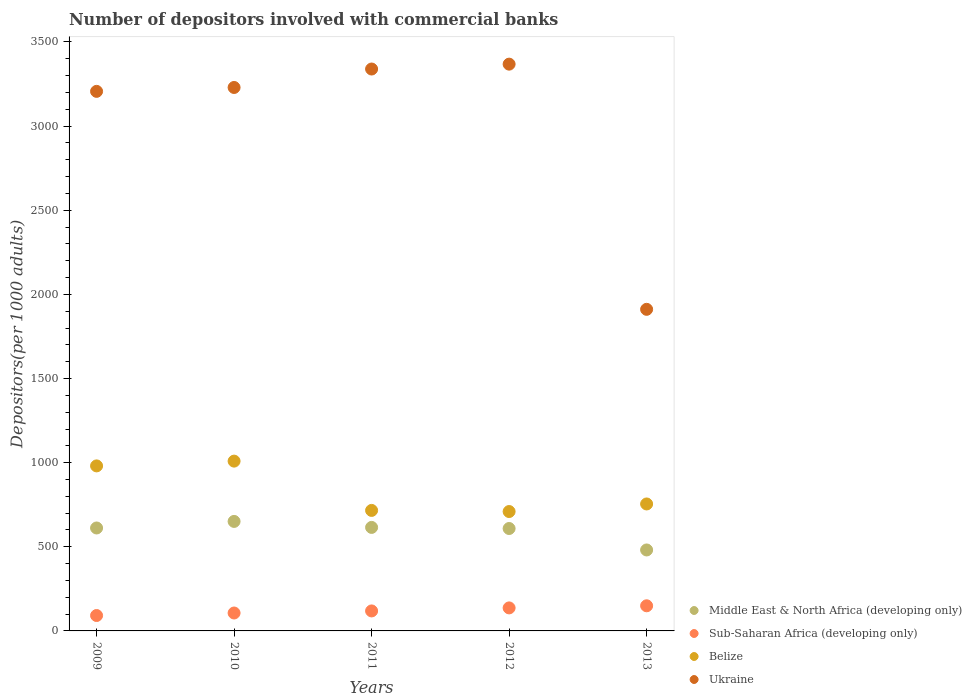How many different coloured dotlines are there?
Provide a short and direct response. 4. What is the number of depositors involved with commercial banks in Belize in 2013?
Ensure brevity in your answer.  754.53. Across all years, what is the maximum number of depositors involved with commercial banks in Ukraine?
Your response must be concise. 3368.39. Across all years, what is the minimum number of depositors involved with commercial banks in Middle East & North Africa (developing only)?
Provide a short and direct response. 481.17. In which year was the number of depositors involved with commercial banks in Ukraine minimum?
Provide a succinct answer. 2013. What is the total number of depositors involved with commercial banks in Ukraine in the graph?
Offer a terse response. 1.51e+04. What is the difference between the number of depositors involved with commercial banks in Sub-Saharan Africa (developing only) in 2011 and that in 2012?
Ensure brevity in your answer.  -17.98. What is the difference between the number of depositors involved with commercial banks in Sub-Saharan Africa (developing only) in 2009 and the number of depositors involved with commercial banks in Belize in 2012?
Provide a succinct answer. -617.99. What is the average number of depositors involved with commercial banks in Belize per year?
Make the answer very short. 834.02. In the year 2012, what is the difference between the number of depositors involved with commercial banks in Ukraine and number of depositors involved with commercial banks in Sub-Saharan Africa (developing only)?
Make the answer very short. 3231.6. In how many years, is the number of depositors involved with commercial banks in Ukraine greater than 2000?
Ensure brevity in your answer.  4. What is the ratio of the number of depositors involved with commercial banks in Ukraine in 2011 to that in 2013?
Make the answer very short. 1.75. Is the number of depositors involved with commercial banks in Sub-Saharan Africa (developing only) in 2009 less than that in 2010?
Ensure brevity in your answer.  Yes. What is the difference between the highest and the second highest number of depositors involved with commercial banks in Ukraine?
Your answer should be very brief. 28.98. What is the difference between the highest and the lowest number of depositors involved with commercial banks in Middle East & North Africa (developing only)?
Make the answer very short. 169.6. Is it the case that in every year, the sum of the number of depositors involved with commercial banks in Middle East & North Africa (developing only) and number of depositors involved with commercial banks in Belize  is greater than the sum of number of depositors involved with commercial banks in Sub-Saharan Africa (developing only) and number of depositors involved with commercial banks in Ukraine?
Your response must be concise. Yes. Is it the case that in every year, the sum of the number of depositors involved with commercial banks in Belize and number of depositors involved with commercial banks in Middle East & North Africa (developing only)  is greater than the number of depositors involved with commercial banks in Ukraine?
Offer a very short reply. No. Is the number of depositors involved with commercial banks in Ukraine strictly less than the number of depositors involved with commercial banks in Sub-Saharan Africa (developing only) over the years?
Your response must be concise. No. Does the graph contain grids?
Your response must be concise. No. Where does the legend appear in the graph?
Offer a very short reply. Bottom right. What is the title of the graph?
Ensure brevity in your answer.  Number of depositors involved with commercial banks. Does "Eritrea" appear as one of the legend labels in the graph?
Provide a short and direct response. No. What is the label or title of the Y-axis?
Keep it short and to the point. Depositors(per 1000 adults). What is the Depositors(per 1000 adults) of Middle East & North Africa (developing only) in 2009?
Provide a short and direct response. 611.77. What is the Depositors(per 1000 adults) in Sub-Saharan Africa (developing only) in 2009?
Provide a succinct answer. 91.54. What is the Depositors(per 1000 adults) of Belize in 2009?
Give a very brief answer. 980.77. What is the Depositors(per 1000 adults) of Ukraine in 2009?
Make the answer very short. 3206.64. What is the Depositors(per 1000 adults) in Middle East & North Africa (developing only) in 2010?
Offer a terse response. 650.77. What is the Depositors(per 1000 adults) in Sub-Saharan Africa (developing only) in 2010?
Make the answer very short. 106.49. What is the Depositors(per 1000 adults) in Belize in 2010?
Your response must be concise. 1009.11. What is the Depositors(per 1000 adults) in Ukraine in 2010?
Provide a short and direct response. 3229.69. What is the Depositors(per 1000 adults) of Middle East & North Africa (developing only) in 2011?
Provide a short and direct response. 615.16. What is the Depositors(per 1000 adults) of Sub-Saharan Africa (developing only) in 2011?
Offer a terse response. 118.8. What is the Depositors(per 1000 adults) of Belize in 2011?
Your answer should be compact. 716.16. What is the Depositors(per 1000 adults) of Ukraine in 2011?
Offer a very short reply. 3339.41. What is the Depositors(per 1000 adults) in Middle East & North Africa (developing only) in 2012?
Keep it short and to the point. 608.64. What is the Depositors(per 1000 adults) in Sub-Saharan Africa (developing only) in 2012?
Provide a succinct answer. 136.78. What is the Depositors(per 1000 adults) of Belize in 2012?
Your answer should be compact. 709.54. What is the Depositors(per 1000 adults) of Ukraine in 2012?
Provide a short and direct response. 3368.39. What is the Depositors(per 1000 adults) of Middle East & North Africa (developing only) in 2013?
Offer a terse response. 481.17. What is the Depositors(per 1000 adults) in Sub-Saharan Africa (developing only) in 2013?
Your answer should be compact. 149.33. What is the Depositors(per 1000 adults) in Belize in 2013?
Your answer should be compact. 754.53. What is the Depositors(per 1000 adults) of Ukraine in 2013?
Make the answer very short. 1911.24. Across all years, what is the maximum Depositors(per 1000 adults) of Middle East & North Africa (developing only)?
Ensure brevity in your answer.  650.77. Across all years, what is the maximum Depositors(per 1000 adults) of Sub-Saharan Africa (developing only)?
Give a very brief answer. 149.33. Across all years, what is the maximum Depositors(per 1000 adults) of Belize?
Offer a terse response. 1009.11. Across all years, what is the maximum Depositors(per 1000 adults) in Ukraine?
Make the answer very short. 3368.39. Across all years, what is the minimum Depositors(per 1000 adults) of Middle East & North Africa (developing only)?
Offer a very short reply. 481.17. Across all years, what is the minimum Depositors(per 1000 adults) in Sub-Saharan Africa (developing only)?
Ensure brevity in your answer.  91.54. Across all years, what is the minimum Depositors(per 1000 adults) in Belize?
Keep it short and to the point. 709.54. Across all years, what is the minimum Depositors(per 1000 adults) in Ukraine?
Provide a short and direct response. 1911.24. What is the total Depositors(per 1000 adults) in Middle East & North Africa (developing only) in the graph?
Your answer should be compact. 2967.5. What is the total Depositors(per 1000 adults) of Sub-Saharan Africa (developing only) in the graph?
Provide a short and direct response. 602.95. What is the total Depositors(per 1000 adults) of Belize in the graph?
Ensure brevity in your answer.  4170.11. What is the total Depositors(per 1000 adults) in Ukraine in the graph?
Give a very brief answer. 1.51e+04. What is the difference between the Depositors(per 1000 adults) in Middle East & North Africa (developing only) in 2009 and that in 2010?
Provide a succinct answer. -39. What is the difference between the Depositors(per 1000 adults) of Sub-Saharan Africa (developing only) in 2009 and that in 2010?
Keep it short and to the point. -14.95. What is the difference between the Depositors(per 1000 adults) of Belize in 2009 and that in 2010?
Make the answer very short. -28.34. What is the difference between the Depositors(per 1000 adults) of Ukraine in 2009 and that in 2010?
Provide a succinct answer. -23.06. What is the difference between the Depositors(per 1000 adults) in Middle East & North Africa (developing only) in 2009 and that in 2011?
Offer a very short reply. -3.39. What is the difference between the Depositors(per 1000 adults) in Sub-Saharan Africa (developing only) in 2009 and that in 2011?
Ensure brevity in your answer.  -27.26. What is the difference between the Depositors(per 1000 adults) in Belize in 2009 and that in 2011?
Your response must be concise. 264.62. What is the difference between the Depositors(per 1000 adults) of Ukraine in 2009 and that in 2011?
Make the answer very short. -132.77. What is the difference between the Depositors(per 1000 adults) in Middle East & North Africa (developing only) in 2009 and that in 2012?
Offer a terse response. 3.13. What is the difference between the Depositors(per 1000 adults) in Sub-Saharan Africa (developing only) in 2009 and that in 2012?
Your answer should be compact. -45.24. What is the difference between the Depositors(per 1000 adults) in Belize in 2009 and that in 2012?
Provide a short and direct response. 271.24. What is the difference between the Depositors(per 1000 adults) in Ukraine in 2009 and that in 2012?
Offer a very short reply. -161.75. What is the difference between the Depositors(per 1000 adults) in Middle East & North Africa (developing only) in 2009 and that in 2013?
Offer a terse response. 130.6. What is the difference between the Depositors(per 1000 adults) of Sub-Saharan Africa (developing only) in 2009 and that in 2013?
Your response must be concise. -57.79. What is the difference between the Depositors(per 1000 adults) in Belize in 2009 and that in 2013?
Offer a very short reply. 226.24. What is the difference between the Depositors(per 1000 adults) in Ukraine in 2009 and that in 2013?
Provide a short and direct response. 1295.4. What is the difference between the Depositors(per 1000 adults) of Middle East & North Africa (developing only) in 2010 and that in 2011?
Your answer should be compact. 35.61. What is the difference between the Depositors(per 1000 adults) of Sub-Saharan Africa (developing only) in 2010 and that in 2011?
Your answer should be compact. -12.31. What is the difference between the Depositors(per 1000 adults) of Belize in 2010 and that in 2011?
Ensure brevity in your answer.  292.95. What is the difference between the Depositors(per 1000 adults) in Ukraine in 2010 and that in 2011?
Your response must be concise. -109.71. What is the difference between the Depositors(per 1000 adults) of Middle East & North Africa (developing only) in 2010 and that in 2012?
Offer a very short reply. 42.13. What is the difference between the Depositors(per 1000 adults) in Sub-Saharan Africa (developing only) in 2010 and that in 2012?
Offer a very short reply. -30.29. What is the difference between the Depositors(per 1000 adults) in Belize in 2010 and that in 2012?
Provide a short and direct response. 299.57. What is the difference between the Depositors(per 1000 adults) in Ukraine in 2010 and that in 2012?
Your answer should be very brief. -138.7. What is the difference between the Depositors(per 1000 adults) in Middle East & North Africa (developing only) in 2010 and that in 2013?
Offer a very short reply. 169.6. What is the difference between the Depositors(per 1000 adults) in Sub-Saharan Africa (developing only) in 2010 and that in 2013?
Give a very brief answer. -42.84. What is the difference between the Depositors(per 1000 adults) of Belize in 2010 and that in 2013?
Your response must be concise. 254.58. What is the difference between the Depositors(per 1000 adults) of Ukraine in 2010 and that in 2013?
Offer a very short reply. 1318.46. What is the difference between the Depositors(per 1000 adults) of Middle East & North Africa (developing only) in 2011 and that in 2012?
Your answer should be very brief. 6.52. What is the difference between the Depositors(per 1000 adults) of Sub-Saharan Africa (developing only) in 2011 and that in 2012?
Your response must be concise. -17.98. What is the difference between the Depositors(per 1000 adults) in Belize in 2011 and that in 2012?
Ensure brevity in your answer.  6.62. What is the difference between the Depositors(per 1000 adults) in Ukraine in 2011 and that in 2012?
Provide a short and direct response. -28.98. What is the difference between the Depositors(per 1000 adults) in Middle East & North Africa (developing only) in 2011 and that in 2013?
Give a very brief answer. 133.99. What is the difference between the Depositors(per 1000 adults) in Sub-Saharan Africa (developing only) in 2011 and that in 2013?
Your answer should be very brief. -30.53. What is the difference between the Depositors(per 1000 adults) of Belize in 2011 and that in 2013?
Your answer should be very brief. -38.37. What is the difference between the Depositors(per 1000 adults) of Ukraine in 2011 and that in 2013?
Your answer should be very brief. 1428.17. What is the difference between the Depositors(per 1000 adults) in Middle East & North Africa (developing only) in 2012 and that in 2013?
Your answer should be very brief. 127.47. What is the difference between the Depositors(per 1000 adults) in Sub-Saharan Africa (developing only) in 2012 and that in 2013?
Ensure brevity in your answer.  -12.55. What is the difference between the Depositors(per 1000 adults) in Belize in 2012 and that in 2013?
Offer a very short reply. -44.99. What is the difference between the Depositors(per 1000 adults) in Ukraine in 2012 and that in 2013?
Give a very brief answer. 1457.15. What is the difference between the Depositors(per 1000 adults) in Middle East & North Africa (developing only) in 2009 and the Depositors(per 1000 adults) in Sub-Saharan Africa (developing only) in 2010?
Offer a very short reply. 505.28. What is the difference between the Depositors(per 1000 adults) in Middle East & North Africa (developing only) in 2009 and the Depositors(per 1000 adults) in Belize in 2010?
Your answer should be compact. -397.35. What is the difference between the Depositors(per 1000 adults) of Middle East & North Africa (developing only) in 2009 and the Depositors(per 1000 adults) of Ukraine in 2010?
Give a very brief answer. -2617.93. What is the difference between the Depositors(per 1000 adults) of Sub-Saharan Africa (developing only) in 2009 and the Depositors(per 1000 adults) of Belize in 2010?
Provide a short and direct response. -917.57. What is the difference between the Depositors(per 1000 adults) of Sub-Saharan Africa (developing only) in 2009 and the Depositors(per 1000 adults) of Ukraine in 2010?
Make the answer very short. -3138.15. What is the difference between the Depositors(per 1000 adults) in Belize in 2009 and the Depositors(per 1000 adults) in Ukraine in 2010?
Your answer should be compact. -2248.92. What is the difference between the Depositors(per 1000 adults) of Middle East & North Africa (developing only) in 2009 and the Depositors(per 1000 adults) of Sub-Saharan Africa (developing only) in 2011?
Ensure brevity in your answer.  492.96. What is the difference between the Depositors(per 1000 adults) of Middle East & North Africa (developing only) in 2009 and the Depositors(per 1000 adults) of Belize in 2011?
Provide a succinct answer. -104.39. What is the difference between the Depositors(per 1000 adults) in Middle East & North Africa (developing only) in 2009 and the Depositors(per 1000 adults) in Ukraine in 2011?
Your response must be concise. -2727.64. What is the difference between the Depositors(per 1000 adults) of Sub-Saharan Africa (developing only) in 2009 and the Depositors(per 1000 adults) of Belize in 2011?
Keep it short and to the point. -624.61. What is the difference between the Depositors(per 1000 adults) of Sub-Saharan Africa (developing only) in 2009 and the Depositors(per 1000 adults) of Ukraine in 2011?
Give a very brief answer. -3247.86. What is the difference between the Depositors(per 1000 adults) of Belize in 2009 and the Depositors(per 1000 adults) of Ukraine in 2011?
Ensure brevity in your answer.  -2358.63. What is the difference between the Depositors(per 1000 adults) of Middle East & North Africa (developing only) in 2009 and the Depositors(per 1000 adults) of Sub-Saharan Africa (developing only) in 2012?
Your response must be concise. 474.98. What is the difference between the Depositors(per 1000 adults) in Middle East & North Africa (developing only) in 2009 and the Depositors(per 1000 adults) in Belize in 2012?
Ensure brevity in your answer.  -97.77. What is the difference between the Depositors(per 1000 adults) in Middle East & North Africa (developing only) in 2009 and the Depositors(per 1000 adults) in Ukraine in 2012?
Make the answer very short. -2756.62. What is the difference between the Depositors(per 1000 adults) of Sub-Saharan Africa (developing only) in 2009 and the Depositors(per 1000 adults) of Belize in 2012?
Offer a very short reply. -617.99. What is the difference between the Depositors(per 1000 adults) in Sub-Saharan Africa (developing only) in 2009 and the Depositors(per 1000 adults) in Ukraine in 2012?
Your answer should be very brief. -3276.85. What is the difference between the Depositors(per 1000 adults) of Belize in 2009 and the Depositors(per 1000 adults) of Ukraine in 2012?
Offer a very short reply. -2387.62. What is the difference between the Depositors(per 1000 adults) in Middle East & North Africa (developing only) in 2009 and the Depositors(per 1000 adults) in Sub-Saharan Africa (developing only) in 2013?
Offer a very short reply. 462.43. What is the difference between the Depositors(per 1000 adults) in Middle East & North Africa (developing only) in 2009 and the Depositors(per 1000 adults) in Belize in 2013?
Your answer should be compact. -142.76. What is the difference between the Depositors(per 1000 adults) of Middle East & North Africa (developing only) in 2009 and the Depositors(per 1000 adults) of Ukraine in 2013?
Give a very brief answer. -1299.47. What is the difference between the Depositors(per 1000 adults) of Sub-Saharan Africa (developing only) in 2009 and the Depositors(per 1000 adults) of Belize in 2013?
Keep it short and to the point. -662.99. What is the difference between the Depositors(per 1000 adults) of Sub-Saharan Africa (developing only) in 2009 and the Depositors(per 1000 adults) of Ukraine in 2013?
Make the answer very short. -1819.69. What is the difference between the Depositors(per 1000 adults) of Belize in 2009 and the Depositors(per 1000 adults) of Ukraine in 2013?
Give a very brief answer. -930.46. What is the difference between the Depositors(per 1000 adults) of Middle East & North Africa (developing only) in 2010 and the Depositors(per 1000 adults) of Sub-Saharan Africa (developing only) in 2011?
Give a very brief answer. 531.96. What is the difference between the Depositors(per 1000 adults) of Middle East & North Africa (developing only) in 2010 and the Depositors(per 1000 adults) of Belize in 2011?
Keep it short and to the point. -65.39. What is the difference between the Depositors(per 1000 adults) in Middle East & North Africa (developing only) in 2010 and the Depositors(per 1000 adults) in Ukraine in 2011?
Offer a terse response. -2688.64. What is the difference between the Depositors(per 1000 adults) in Sub-Saharan Africa (developing only) in 2010 and the Depositors(per 1000 adults) in Belize in 2011?
Your response must be concise. -609.67. What is the difference between the Depositors(per 1000 adults) of Sub-Saharan Africa (developing only) in 2010 and the Depositors(per 1000 adults) of Ukraine in 2011?
Ensure brevity in your answer.  -3232.92. What is the difference between the Depositors(per 1000 adults) of Belize in 2010 and the Depositors(per 1000 adults) of Ukraine in 2011?
Make the answer very short. -2330.29. What is the difference between the Depositors(per 1000 adults) of Middle East & North Africa (developing only) in 2010 and the Depositors(per 1000 adults) of Sub-Saharan Africa (developing only) in 2012?
Provide a succinct answer. 513.98. What is the difference between the Depositors(per 1000 adults) of Middle East & North Africa (developing only) in 2010 and the Depositors(per 1000 adults) of Belize in 2012?
Your answer should be compact. -58.77. What is the difference between the Depositors(per 1000 adults) in Middle East & North Africa (developing only) in 2010 and the Depositors(per 1000 adults) in Ukraine in 2012?
Offer a very short reply. -2717.62. What is the difference between the Depositors(per 1000 adults) of Sub-Saharan Africa (developing only) in 2010 and the Depositors(per 1000 adults) of Belize in 2012?
Offer a very short reply. -603.05. What is the difference between the Depositors(per 1000 adults) of Sub-Saharan Africa (developing only) in 2010 and the Depositors(per 1000 adults) of Ukraine in 2012?
Keep it short and to the point. -3261.9. What is the difference between the Depositors(per 1000 adults) of Belize in 2010 and the Depositors(per 1000 adults) of Ukraine in 2012?
Make the answer very short. -2359.28. What is the difference between the Depositors(per 1000 adults) of Middle East & North Africa (developing only) in 2010 and the Depositors(per 1000 adults) of Sub-Saharan Africa (developing only) in 2013?
Your response must be concise. 501.43. What is the difference between the Depositors(per 1000 adults) in Middle East & North Africa (developing only) in 2010 and the Depositors(per 1000 adults) in Belize in 2013?
Provide a short and direct response. -103.76. What is the difference between the Depositors(per 1000 adults) of Middle East & North Africa (developing only) in 2010 and the Depositors(per 1000 adults) of Ukraine in 2013?
Offer a terse response. -1260.47. What is the difference between the Depositors(per 1000 adults) of Sub-Saharan Africa (developing only) in 2010 and the Depositors(per 1000 adults) of Belize in 2013?
Your answer should be compact. -648.04. What is the difference between the Depositors(per 1000 adults) in Sub-Saharan Africa (developing only) in 2010 and the Depositors(per 1000 adults) in Ukraine in 2013?
Keep it short and to the point. -1804.75. What is the difference between the Depositors(per 1000 adults) of Belize in 2010 and the Depositors(per 1000 adults) of Ukraine in 2013?
Provide a succinct answer. -902.12. What is the difference between the Depositors(per 1000 adults) of Middle East & North Africa (developing only) in 2011 and the Depositors(per 1000 adults) of Sub-Saharan Africa (developing only) in 2012?
Your answer should be compact. 478.37. What is the difference between the Depositors(per 1000 adults) of Middle East & North Africa (developing only) in 2011 and the Depositors(per 1000 adults) of Belize in 2012?
Offer a terse response. -94.38. What is the difference between the Depositors(per 1000 adults) in Middle East & North Africa (developing only) in 2011 and the Depositors(per 1000 adults) in Ukraine in 2012?
Provide a short and direct response. -2753.23. What is the difference between the Depositors(per 1000 adults) of Sub-Saharan Africa (developing only) in 2011 and the Depositors(per 1000 adults) of Belize in 2012?
Your answer should be compact. -590.73. What is the difference between the Depositors(per 1000 adults) in Sub-Saharan Africa (developing only) in 2011 and the Depositors(per 1000 adults) in Ukraine in 2012?
Your answer should be very brief. -3249.58. What is the difference between the Depositors(per 1000 adults) in Belize in 2011 and the Depositors(per 1000 adults) in Ukraine in 2012?
Your response must be concise. -2652.23. What is the difference between the Depositors(per 1000 adults) in Middle East & North Africa (developing only) in 2011 and the Depositors(per 1000 adults) in Sub-Saharan Africa (developing only) in 2013?
Your response must be concise. 465.82. What is the difference between the Depositors(per 1000 adults) of Middle East & North Africa (developing only) in 2011 and the Depositors(per 1000 adults) of Belize in 2013?
Ensure brevity in your answer.  -139.37. What is the difference between the Depositors(per 1000 adults) in Middle East & North Africa (developing only) in 2011 and the Depositors(per 1000 adults) in Ukraine in 2013?
Give a very brief answer. -1296.08. What is the difference between the Depositors(per 1000 adults) in Sub-Saharan Africa (developing only) in 2011 and the Depositors(per 1000 adults) in Belize in 2013?
Your answer should be very brief. -635.72. What is the difference between the Depositors(per 1000 adults) of Sub-Saharan Africa (developing only) in 2011 and the Depositors(per 1000 adults) of Ukraine in 2013?
Your response must be concise. -1792.43. What is the difference between the Depositors(per 1000 adults) in Belize in 2011 and the Depositors(per 1000 adults) in Ukraine in 2013?
Provide a succinct answer. -1195.08. What is the difference between the Depositors(per 1000 adults) of Middle East & North Africa (developing only) in 2012 and the Depositors(per 1000 adults) of Sub-Saharan Africa (developing only) in 2013?
Provide a succinct answer. 459.31. What is the difference between the Depositors(per 1000 adults) of Middle East & North Africa (developing only) in 2012 and the Depositors(per 1000 adults) of Belize in 2013?
Give a very brief answer. -145.89. What is the difference between the Depositors(per 1000 adults) of Middle East & North Africa (developing only) in 2012 and the Depositors(per 1000 adults) of Ukraine in 2013?
Offer a very short reply. -1302.6. What is the difference between the Depositors(per 1000 adults) in Sub-Saharan Africa (developing only) in 2012 and the Depositors(per 1000 adults) in Belize in 2013?
Offer a terse response. -617.74. What is the difference between the Depositors(per 1000 adults) of Sub-Saharan Africa (developing only) in 2012 and the Depositors(per 1000 adults) of Ukraine in 2013?
Make the answer very short. -1774.45. What is the difference between the Depositors(per 1000 adults) of Belize in 2012 and the Depositors(per 1000 adults) of Ukraine in 2013?
Keep it short and to the point. -1201.7. What is the average Depositors(per 1000 adults) in Middle East & North Africa (developing only) per year?
Your response must be concise. 593.5. What is the average Depositors(per 1000 adults) of Sub-Saharan Africa (developing only) per year?
Your response must be concise. 120.59. What is the average Depositors(per 1000 adults) of Belize per year?
Make the answer very short. 834.02. What is the average Depositors(per 1000 adults) of Ukraine per year?
Your answer should be very brief. 3011.07. In the year 2009, what is the difference between the Depositors(per 1000 adults) of Middle East & North Africa (developing only) and Depositors(per 1000 adults) of Sub-Saharan Africa (developing only)?
Your answer should be compact. 520.22. In the year 2009, what is the difference between the Depositors(per 1000 adults) in Middle East & North Africa (developing only) and Depositors(per 1000 adults) in Belize?
Make the answer very short. -369.01. In the year 2009, what is the difference between the Depositors(per 1000 adults) of Middle East & North Africa (developing only) and Depositors(per 1000 adults) of Ukraine?
Make the answer very short. -2594.87. In the year 2009, what is the difference between the Depositors(per 1000 adults) in Sub-Saharan Africa (developing only) and Depositors(per 1000 adults) in Belize?
Offer a terse response. -889.23. In the year 2009, what is the difference between the Depositors(per 1000 adults) in Sub-Saharan Africa (developing only) and Depositors(per 1000 adults) in Ukraine?
Give a very brief answer. -3115.09. In the year 2009, what is the difference between the Depositors(per 1000 adults) of Belize and Depositors(per 1000 adults) of Ukraine?
Ensure brevity in your answer.  -2225.86. In the year 2010, what is the difference between the Depositors(per 1000 adults) of Middle East & North Africa (developing only) and Depositors(per 1000 adults) of Sub-Saharan Africa (developing only)?
Your answer should be very brief. 544.28. In the year 2010, what is the difference between the Depositors(per 1000 adults) in Middle East & North Africa (developing only) and Depositors(per 1000 adults) in Belize?
Offer a very short reply. -358.35. In the year 2010, what is the difference between the Depositors(per 1000 adults) in Middle East & North Africa (developing only) and Depositors(per 1000 adults) in Ukraine?
Offer a terse response. -2578.93. In the year 2010, what is the difference between the Depositors(per 1000 adults) in Sub-Saharan Africa (developing only) and Depositors(per 1000 adults) in Belize?
Make the answer very short. -902.62. In the year 2010, what is the difference between the Depositors(per 1000 adults) in Sub-Saharan Africa (developing only) and Depositors(per 1000 adults) in Ukraine?
Provide a succinct answer. -3123.2. In the year 2010, what is the difference between the Depositors(per 1000 adults) in Belize and Depositors(per 1000 adults) in Ukraine?
Make the answer very short. -2220.58. In the year 2011, what is the difference between the Depositors(per 1000 adults) of Middle East & North Africa (developing only) and Depositors(per 1000 adults) of Sub-Saharan Africa (developing only)?
Your response must be concise. 496.35. In the year 2011, what is the difference between the Depositors(per 1000 adults) of Middle East & North Africa (developing only) and Depositors(per 1000 adults) of Belize?
Your answer should be very brief. -101. In the year 2011, what is the difference between the Depositors(per 1000 adults) of Middle East & North Africa (developing only) and Depositors(per 1000 adults) of Ukraine?
Your response must be concise. -2724.25. In the year 2011, what is the difference between the Depositors(per 1000 adults) in Sub-Saharan Africa (developing only) and Depositors(per 1000 adults) in Belize?
Your answer should be very brief. -597.35. In the year 2011, what is the difference between the Depositors(per 1000 adults) in Sub-Saharan Africa (developing only) and Depositors(per 1000 adults) in Ukraine?
Offer a very short reply. -3220.6. In the year 2011, what is the difference between the Depositors(per 1000 adults) in Belize and Depositors(per 1000 adults) in Ukraine?
Provide a short and direct response. -2623.25. In the year 2012, what is the difference between the Depositors(per 1000 adults) in Middle East & North Africa (developing only) and Depositors(per 1000 adults) in Sub-Saharan Africa (developing only)?
Give a very brief answer. 471.86. In the year 2012, what is the difference between the Depositors(per 1000 adults) of Middle East & North Africa (developing only) and Depositors(per 1000 adults) of Belize?
Give a very brief answer. -100.9. In the year 2012, what is the difference between the Depositors(per 1000 adults) of Middle East & North Africa (developing only) and Depositors(per 1000 adults) of Ukraine?
Your answer should be very brief. -2759.75. In the year 2012, what is the difference between the Depositors(per 1000 adults) of Sub-Saharan Africa (developing only) and Depositors(per 1000 adults) of Belize?
Offer a terse response. -572.75. In the year 2012, what is the difference between the Depositors(per 1000 adults) in Sub-Saharan Africa (developing only) and Depositors(per 1000 adults) in Ukraine?
Give a very brief answer. -3231.6. In the year 2012, what is the difference between the Depositors(per 1000 adults) in Belize and Depositors(per 1000 adults) in Ukraine?
Provide a succinct answer. -2658.85. In the year 2013, what is the difference between the Depositors(per 1000 adults) in Middle East & North Africa (developing only) and Depositors(per 1000 adults) in Sub-Saharan Africa (developing only)?
Give a very brief answer. 331.84. In the year 2013, what is the difference between the Depositors(per 1000 adults) of Middle East & North Africa (developing only) and Depositors(per 1000 adults) of Belize?
Provide a succinct answer. -273.36. In the year 2013, what is the difference between the Depositors(per 1000 adults) of Middle East & North Africa (developing only) and Depositors(per 1000 adults) of Ukraine?
Offer a very short reply. -1430.07. In the year 2013, what is the difference between the Depositors(per 1000 adults) of Sub-Saharan Africa (developing only) and Depositors(per 1000 adults) of Belize?
Ensure brevity in your answer.  -605.2. In the year 2013, what is the difference between the Depositors(per 1000 adults) of Sub-Saharan Africa (developing only) and Depositors(per 1000 adults) of Ukraine?
Provide a succinct answer. -1761.9. In the year 2013, what is the difference between the Depositors(per 1000 adults) of Belize and Depositors(per 1000 adults) of Ukraine?
Provide a short and direct response. -1156.71. What is the ratio of the Depositors(per 1000 adults) of Middle East & North Africa (developing only) in 2009 to that in 2010?
Offer a terse response. 0.94. What is the ratio of the Depositors(per 1000 adults) of Sub-Saharan Africa (developing only) in 2009 to that in 2010?
Offer a terse response. 0.86. What is the ratio of the Depositors(per 1000 adults) in Belize in 2009 to that in 2010?
Your answer should be compact. 0.97. What is the ratio of the Depositors(per 1000 adults) of Middle East & North Africa (developing only) in 2009 to that in 2011?
Offer a terse response. 0.99. What is the ratio of the Depositors(per 1000 adults) in Sub-Saharan Africa (developing only) in 2009 to that in 2011?
Ensure brevity in your answer.  0.77. What is the ratio of the Depositors(per 1000 adults) in Belize in 2009 to that in 2011?
Provide a succinct answer. 1.37. What is the ratio of the Depositors(per 1000 adults) in Ukraine in 2009 to that in 2011?
Give a very brief answer. 0.96. What is the ratio of the Depositors(per 1000 adults) in Middle East & North Africa (developing only) in 2009 to that in 2012?
Provide a short and direct response. 1.01. What is the ratio of the Depositors(per 1000 adults) of Sub-Saharan Africa (developing only) in 2009 to that in 2012?
Your answer should be compact. 0.67. What is the ratio of the Depositors(per 1000 adults) in Belize in 2009 to that in 2012?
Your answer should be compact. 1.38. What is the ratio of the Depositors(per 1000 adults) of Ukraine in 2009 to that in 2012?
Ensure brevity in your answer.  0.95. What is the ratio of the Depositors(per 1000 adults) in Middle East & North Africa (developing only) in 2009 to that in 2013?
Your answer should be very brief. 1.27. What is the ratio of the Depositors(per 1000 adults) in Sub-Saharan Africa (developing only) in 2009 to that in 2013?
Provide a short and direct response. 0.61. What is the ratio of the Depositors(per 1000 adults) in Belize in 2009 to that in 2013?
Provide a short and direct response. 1.3. What is the ratio of the Depositors(per 1000 adults) in Ukraine in 2009 to that in 2013?
Offer a terse response. 1.68. What is the ratio of the Depositors(per 1000 adults) in Middle East & North Africa (developing only) in 2010 to that in 2011?
Provide a short and direct response. 1.06. What is the ratio of the Depositors(per 1000 adults) in Sub-Saharan Africa (developing only) in 2010 to that in 2011?
Offer a very short reply. 0.9. What is the ratio of the Depositors(per 1000 adults) of Belize in 2010 to that in 2011?
Your response must be concise. 1.41. What is the ratio of the Depositors(per 1000 adults) in Ukraine in 2010 to that in 2011?
Make the answer very short. 0.97. What is the ratio of the Depositors(per 1000 adults) in Middle East & North Africa (developing only) in 2010 to that in 2012?
Your response must be concise. 1.07. What is the ratio of the Depositors(per 1000 adults) in Sub-Saharan Africa (developing only) in 2010 to that in 2012?
Your answer should be compact. 0.78. What is the ratio of the Depositors(per 1000 adults) in Belize in 2010 to that in 2012?
Keep it short and to the point. 1.42. What is the ratio of the Depositors(per 1000 adults) in Ukraine in 2010 to that in 2012?
Keep it short and to the point. 0.96. What is the ratio of the Depositors(per 1000 adults) of Middle East & North Africa (developing only) in 2010 to that in 2013?
Offer a terse response. 1.35. What is the ratio of the Depositors(per 1000 adults) in Sub-Saharan Africa (developing only) in 2010 to that in 2013?
Offer a very short reply. 0.71. What is the ratio of the Depositors(per 1000 adults) in Belize in 2010 to that in 2013?
Your answer should be very brief. 1.34. What is the ratio of the Depositors(per 1000 adults) in Ukraine in 2010 to that in 2013?
Offer a very short reply. 1.69. What is the ratio of the Depositors(per 1000 adults) of Middle East & North Africa (developing only) in 2011 to that in 2012?
Provide a succinct answer. 1.01. What is the ratio of the Depositors(per 1000 adults) in Sub-Saharan Africa (developing only) in 2011 to that in 2012?
Your answer should be compact. 0.87. What is the ratio of the Depositors(per 1000 adults) in Belize in 2011 to that in 2012?
Your answer should be compact. 1.01. What is the ratio of the Depositors(per 1000 adults) of Ukraine in 2011 to that in 2012?
Keep it short and to the point. 0.99. What is the ratio of the Depositors(per 1000 adults) of Middle East & North Africa (developing only) in 2011 to that in 2013?
Make the answer very short. 1.28. What is the ratio of the Depositors(per 1000 adults) of Sub-Saharan Africa (developing only) in 2011 to that in 2013?
Provide a short and direct response. 0.8. What is the ratio of the Depositors(per 1000 adults) in Belize in 2011 to that in 2013?
Your answer should be compact. 0.95. What is the ratio of the Depositors(per 1000 adults) in Ukraine in 2011 to that in 2013?
Your response must be concise. 1.75. What is the ratio of the Depositors(per 1000 adults) in Middle East & North Africa (developing only) in 2012 to that in 2013?
Offer a very short reply. 1.26. What is the ratio of the Depositors(per 1000 adults) in Sub-Saharan Africa (developing only) in 2012 to that in 2013?
Your answer should be compact. 0.92. What is the ratio of the Depositors(per 1000 adults) in Belize in 2012 to that in 2013?
Provide a succinct answer. 0.94. What is the ratio of the Depositors(per 1000 adults) in Ukraine in 2012 to that in 2013?
Make the answer very short. 1.76. What is the difference between the highest and the second highest Depositors(per 1000 adults) in Middle East & North Africa (developing only)?
Your response must be concise. 35.61. What is the difference between the highest and the second highest Depositors(per 1000 adults) in Sub-Saharan Africa (developing only)?
Keep it short and to the point. 12.55. What is the difference between the highest and the second highest Depositors(per 1000 adults) of Belize?
Make the answer very short. 28.34. What is the difference between the highest and the second highest Depositors(per 1000 adults) of Ukraine?
Your response must be concise. 28.98. What is the difference between the highest and the lowest Depositors(per 1000 adults) of Middle East & North Africa (developing only)?
Your answer should be very brief. 169.6. What is the difference between the highest and the lowest Depositors(per 1000 adults) of Sub-Saharan Africa (developing only)?
Provide a succinct answer. 57.79. What is the difference between the highest and the lowest Depositors(per 1000 adults) of Belize?
Give a very brief answer. 299.57. What is the difference between the highest and the lowest Depositors(per 1000 adults) of Ukraine?
Provide a succinct answer. 1457.15. 